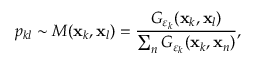<formula> <loc_0><loc_0><loc_500><loc_500>p _ { k l } \sim M ( x _ { k } , x _ { l } ) = \frac { G _ { \varepsilon _ { k } } ( x _ { k } , x _ { l } ) } { \sum _ { n } G _ { \varepsilon _ { k } } ( x _ { k } , x _ { n } ) } ,</formula> 